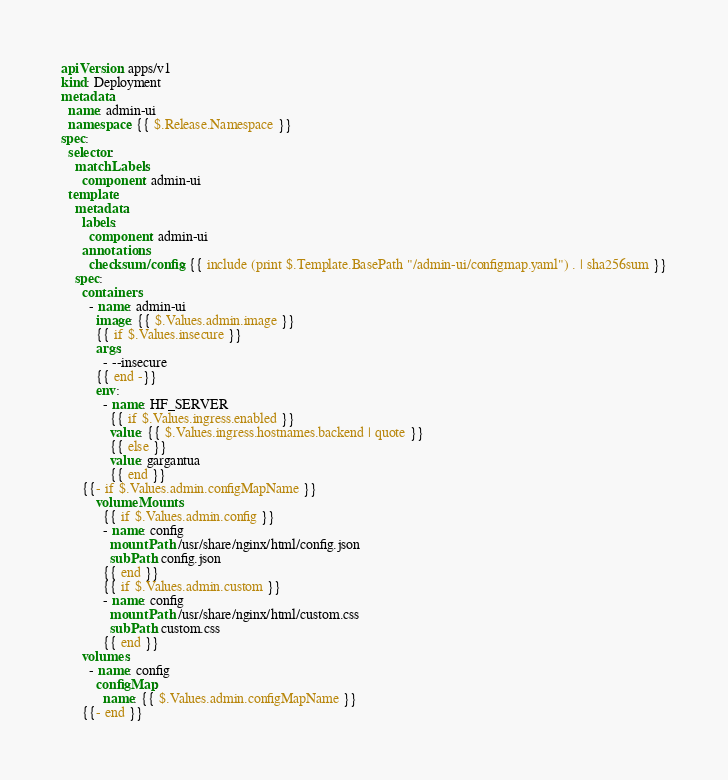<code> <loc_0><loc_0><loc_500><loc_500><_YAML_>apiVersion: apps/v1
kind: Deployment
metadata:
  name: admin-ui
  namespace: {{ $.Release.Namespace }}
spec:
  selector:
    matchLabels:
      component: admin-ui
  template:
    metadata:
      labels:
        component: admin-ui
      annotations:
        checksum/config: {{ include (print $.Template.BasePath "/admin-ui/configmap.yaml") . | sha256sum }}
    spec:
      containers:
        - name: admin-ui
          image: {{ $.Values.admin.image }}
          {{ if $.Values.insecure }}
          args:
            - --insecure
          {{ end -}}
          env:
            - name: HF_SERVER
              {{ if $.Values.ingress.enabled }}
              value: {{ $.Values.ingress.hostnames.backend | quote }}
              {{ else }}
              value: gargantua
              {{ end }}
      {{- if $.Values.admin.configMapName }}
          volumeMounts:
            {{ if $.Values.admin.config }}
            - name: config
              mountPath: /usr/share/nginx/html/config.json
              subPath: config.json
            {{ end }}
            {{ if $.Values.admin.custom }}
            - name: config
              mountPath: /usr/share/nginx/html/custom.css
              subPath: custom.css
            {{ end }}
      volumes:
        - name: config
          configMap: 
            name: {{ $.Values.admin.configMapName }}
      {{- end }}
</code> 